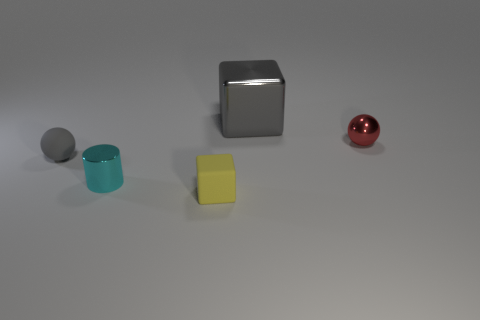Add 4 matte things. How many objects exist? 9 Subtract all blocks. How many objects are left? 3 Subtract all big purple matte cubes. Subtract all cyan shiny objects. How many objects are left? 4 Add 4 large gray things. How many large gray things are left? 5 Add 2 cyan objects. How many cyan objects exist? 3 Subtract 0 purple blocks. How many objects are left? 5 Subtract 2 blocks. How many blocks are left? 0 Subtract all purple balls. Subtract all green cylinders. How many balls are left? 2 